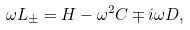Convert formula to latex. <formula><loc_0><loc_0><loc_500><loc_500>\omega L _ { \pm } = H - \omega ^ { 2 } C \mp i \omega D ,</formula> 